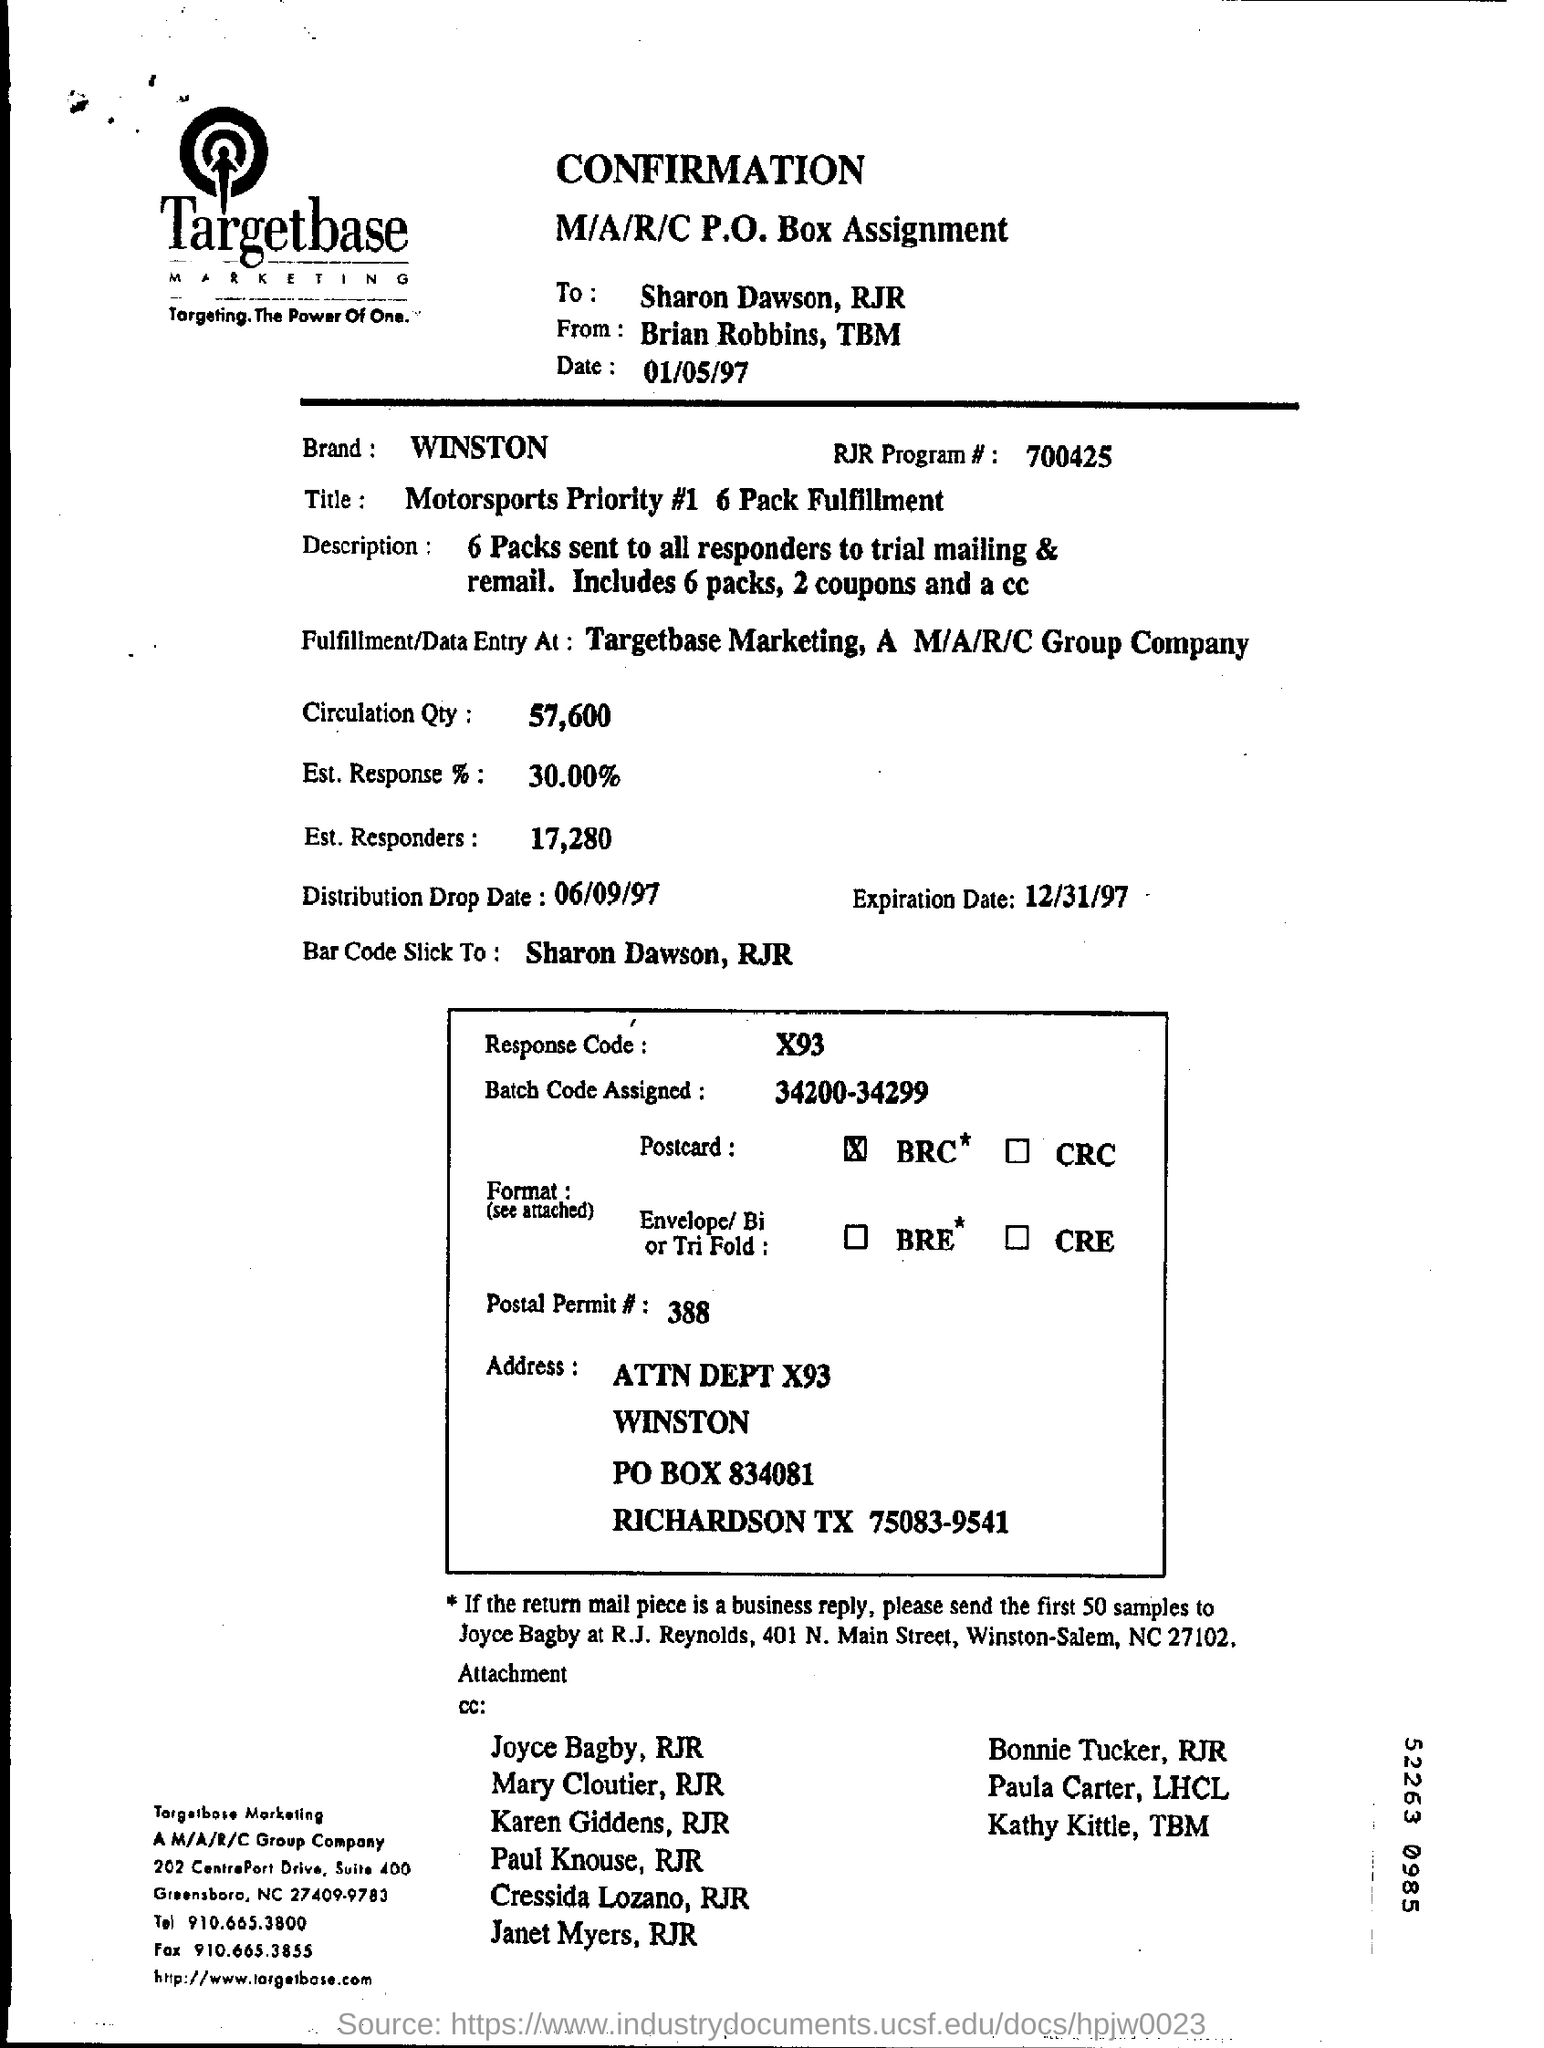List a handful of essential elements in this visual. This document is addressed to Sharon Dawson. What is the Distribution Drop Date? It is 06/09/97. The sender of this message is Brian Robbins and it was sent from the sender's phone number with the prefix "TBM". The response code is X93. The batch code assigned ranges from 34200 to 34299. 